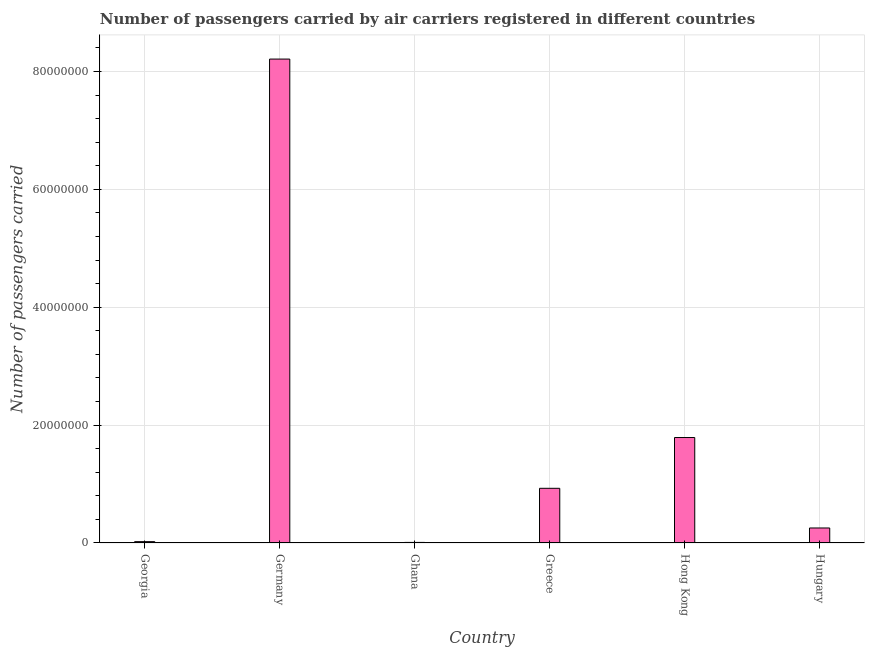What is the title of the graph?
Keep it short and to the point. Number of passengers carried by air carriers registered in different countries. What is the label or title of the Y-axis?
Ensure brevity in your answer.  Number of passengers carried. What is the number of passengers carried in Greece?
Offer a terse response. 9.28e+06. Across all countries, what is the maximum number of passengers carried?
Offer a terse response. 8.21e+07. Across all countries, what is the minimum number of passengers carried?
Your response must be concise. 9.64e+04. In which country was the number of passengers carried minimum?
Offer a terse response. Ghana. What is the sum of the number of passengers carried?
Your response must be concise. 1.12e+08. What is the difference between the number of passengers carried in Ghana and Hong Kong?
Keep it short and to the point. -1.78e+07. What is the average number of passengers carried per country?
Your response must be concise. 1.87e+07. What is the median number of passengers carried?
Your answer should be compact. 5.91e+06. In how many countries, is the number of passengers carried greater than 52000000 ?
Provide a succinct answer. 1. What is the ratio of the number of passengers carried in Hong Kong to that in Hungary?
Offer a very short reply. 7.03. What is the difference between the highest and the second highest number of passengers carried?
Give a very brief answer. 6.42e+07. What is the difference between the highest and the lowest number of passengers carried?
Your answer should be very brief. 8.20e+07. Are all the bars in the graph horizontal?
Make the answer very short. No. How many countries are there in the graph?
Your response must be concise. 6. Are the values on the major ticks of Y-axis written in scientific E-notation?
Offer a terse response. No. What is the Number of passengers carried of Georgia?
Ensure brevity in your answer.  2.29e+05. What is the Number of passengers carried of Germany?
Give a very brief answer. 8.21e+07. What is the Number of passengers carried of Ghana?
Give a very brief answer. 9.64e+04. What is the Number of passengers carried in Greece?
Ensure brevity in your answer.  9.28e+06. What is the Number of passengers carried in Hong Kong?
Your response must be concise. 1.79e+07. What is the Number of passengers carried of Hungary?
Provide a succinct answer. 2.55e+06. What is the difference between the Number of passengers carried in Georgia and Germany?
Make the answer very short. -8.19e+07. What is the difference between the Number of passengers carried in Georgia and Ghana?
Provide a succinct answer. 1.32e+05. What is the difference between the Number of passengers carried in Georgia and Greece?
Give a very brief answer. -9.05e+06. What is the difference between the Number of passengers carried in Georgia and Hong Kong?
Offer a very short reply. -1.77e+07. What is the difference between the Number of passengers carried in Georgia and Hungary?
Give a very brief answer. -2.32e+06. What is the difference between the Number of passengers carried in Germany and Ghana?
Your response must be concise. 8.20e+07. What is the difference between the Number of passengers carried in Germany and Greece?
Provide a short and direct response. 7.28e+07. What is the difference between the Number of passengers carried in Germany and Hong Kong?
Give a very brief answer. 6.42e+07. What is the difference between the Number of passengers carried in Germany and Hungary?
Keep it short and to the point. 7.96e+07. What is the difference between the Number of passengers carried in Ghana and Greece?
Offer a very short reply. -9.18e+06. What is the difference between the Number of passengers carried in Ghana and Hong Kong?
Give a very brief answer. -1.78e+07. What is the difference between the Number of passengers carried in Ghana and Hungary?
Your response must be concise. -2.45e+06. What is the difference between the Number of passengers carried in Greece and Hong Kong?
Your answer should be compact. -8.62e+06. What is the difference between the Number of passengers carried in Greece and Hungary?
Ensure brevity in your answer.  6.73e+06. What is the difference between the Number of passengers carried in Hong Kong and Hungary?
Ensure brevity in your answer.  1.53e+07. What is the ratio of the Number of passengers carried in Georgia to that in Germany?
Give a very brief answer. 0. What is the ratio of the Number of passengers carried in Georgia to that in Ghana?
Keep it short and to the point. 2.37. What is the ratio of the Number of passengers carried in Georgia to that in Greece?
Offer a very short reply. 0.03. What is the ratio of the Number of passengers carried in Georgia to that in Hong Kong?
Your response must be concise. 0.01. What is the ratio of the Number of passengers carried in Georgia to that in Hungary?
Keep it short and to the point. 0.09. What is the ratio of the Number of passengers carried in Germany to that in Ghana?
Keep it short and to the point. 851.27. What is the ratio of the Number of passengers carried in Germany to that in Greece?
Keep it short and to the point. 8.85. What is the ratio of the Number of passengers carried in Germany to that in Hong Kong?
Give a very brief answer. 4.59. What is the ratio of the Number of passengers carried in Germany to that in Hungary?
Your answer should be very brief. 32.24. What is the ratio of the Number of passengers carried in Ghana to that in Hong Kong?
Provide a short and direct response. 0.01. What is the ratio of the Number of passengers carried in Ghana to that in Hungary?
Offer a very short reply. 0.04. What is the ratio of the Number of passengers carried in Greece to that in Hong Kong?
Offer a very short reply. 0.52. What is the ratio of the Number of passengers carried in Greece to that in Hungary?
Keep it short and to the point. 3.64. What is the ratio of the Number of passengers carried in Hong Kong to that in Hungary?
Give a very brief answer. 7.03. 